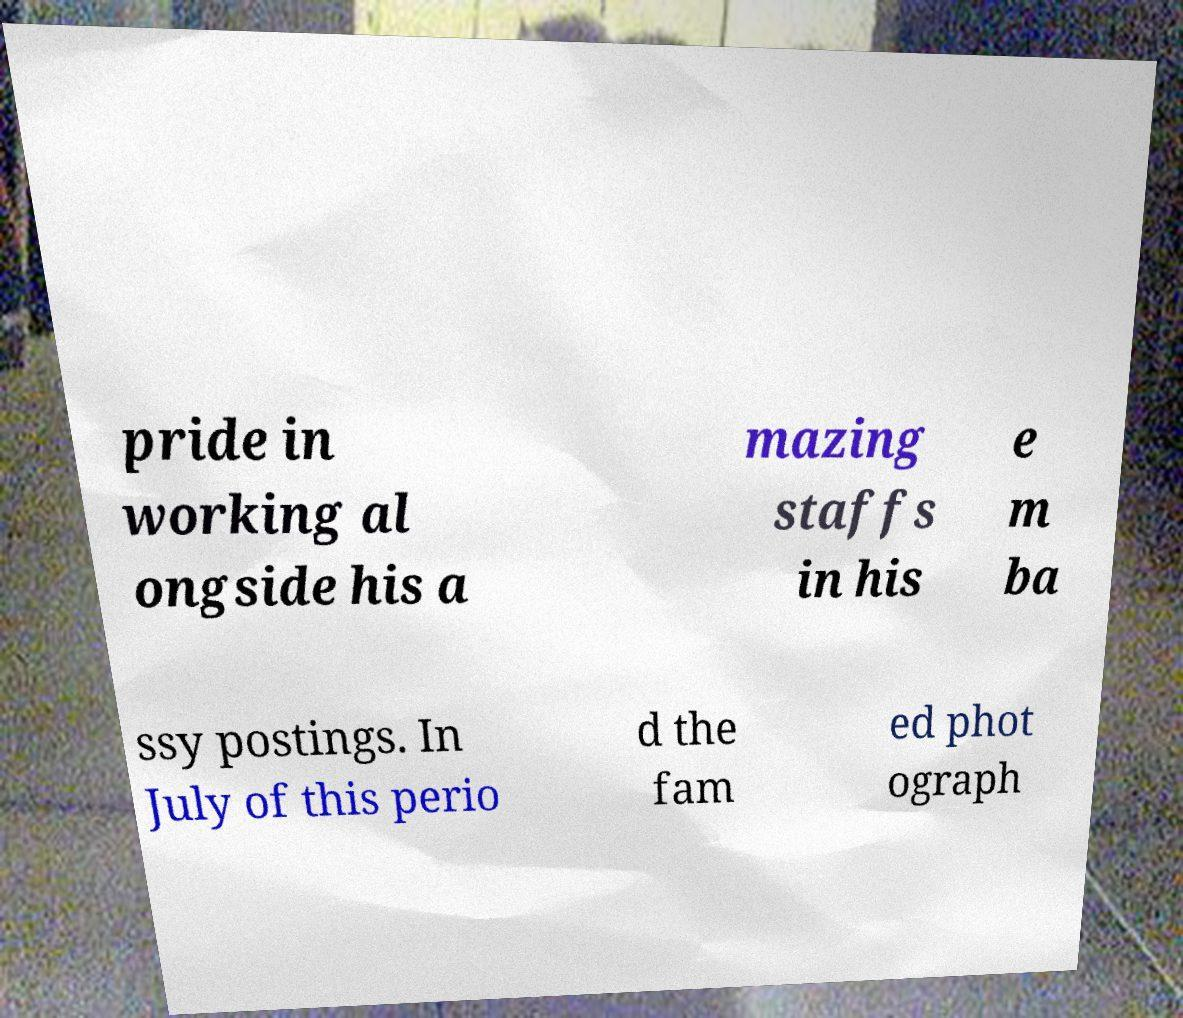Please identify and transcribe the text found in this image. pride in working al ongside his a mazing staffs in his e m ba ssy postings. In July of this perio d the fam ed phot ograph 